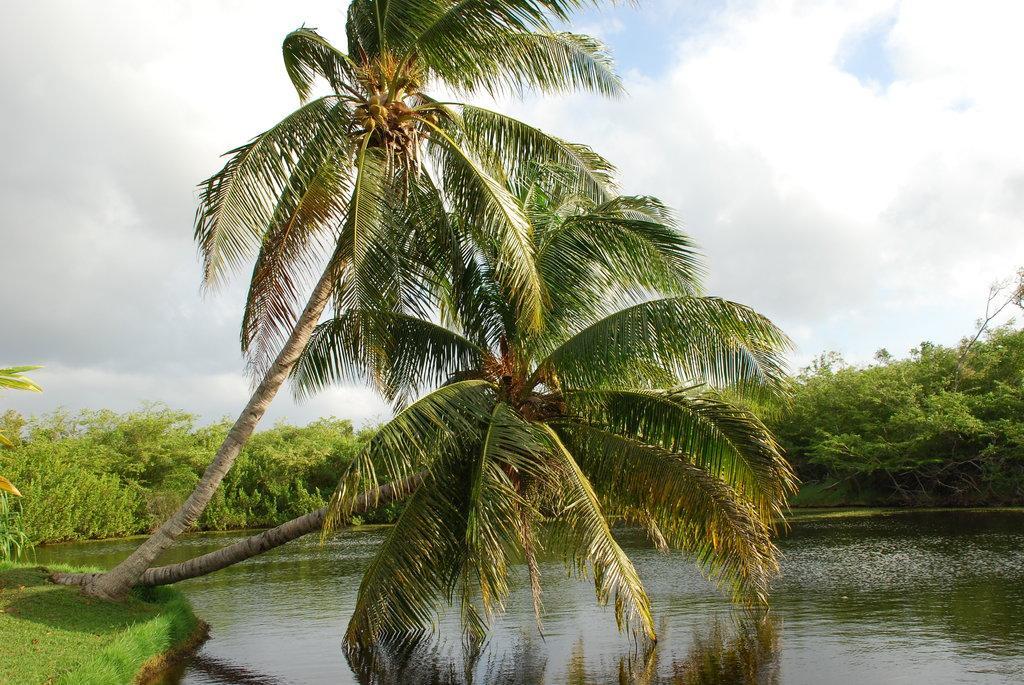In one or two sentences, can you explain what this image depicts? In this image I can see trees in green color, water, and sky in white and blue color. 